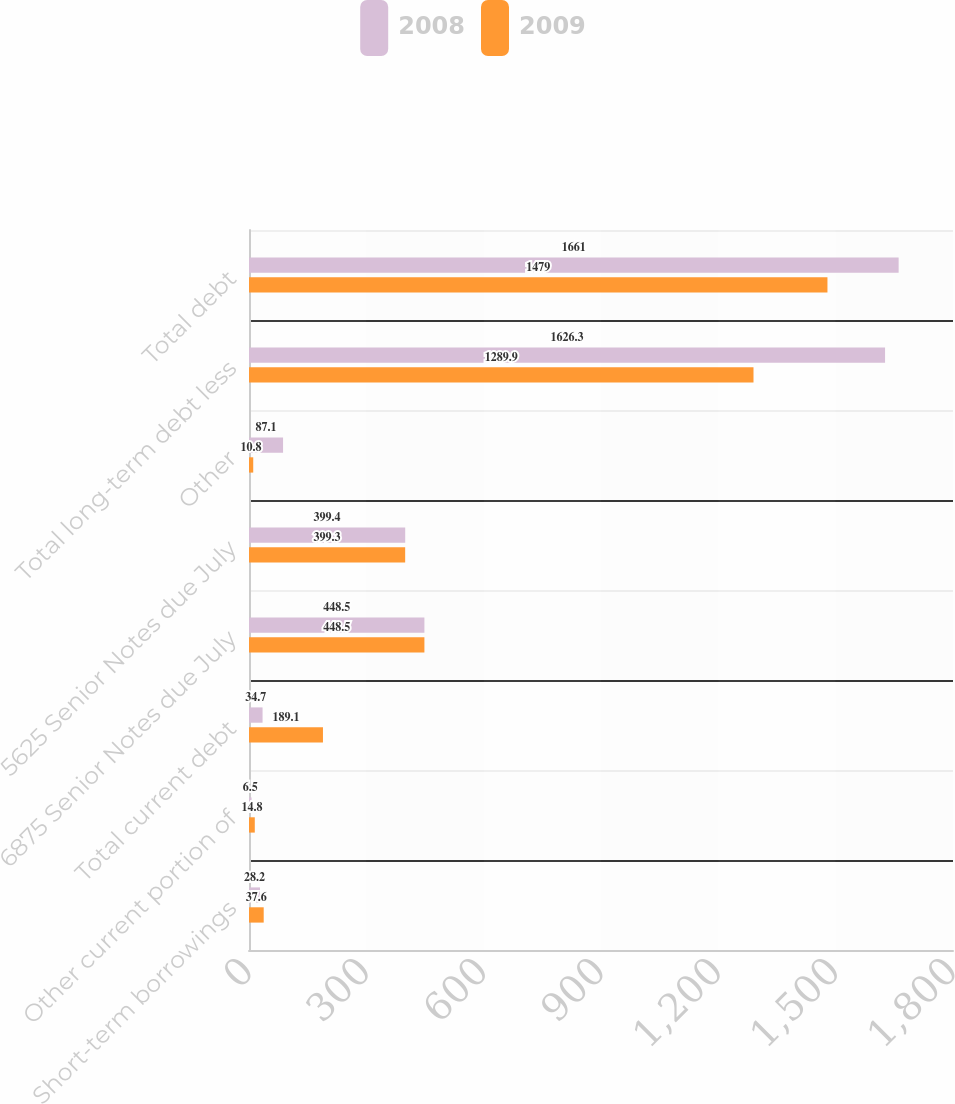Convert chart to OTSL. <chart><loc_0><loc_0><loc_500><loc_500><stacked_bar_chart><ecel><fcel>Short-term borrowings<fcel>Other current portion of<fcel>Total current debt<fcel>6875 Senior Notes due July<fcel>5625 Senior Notes due July<fcel>Other<fcel>Total long-term debt less<fcel>Total debt<nl><fcel>2008<fcel>28.2<fcel>6.5<fcel>34.7<fcel>448.5<fcel>399.4<fcel>87.1<fcel>1626.3<fcel>1661<nl><fcel>2009<fcel>37.6<fcel>14.8<fcel>189.1<fcel>448.5<fcel>399.3<fcel>10.8<fcel>1289.9<fcel>1479<nl></chart> 